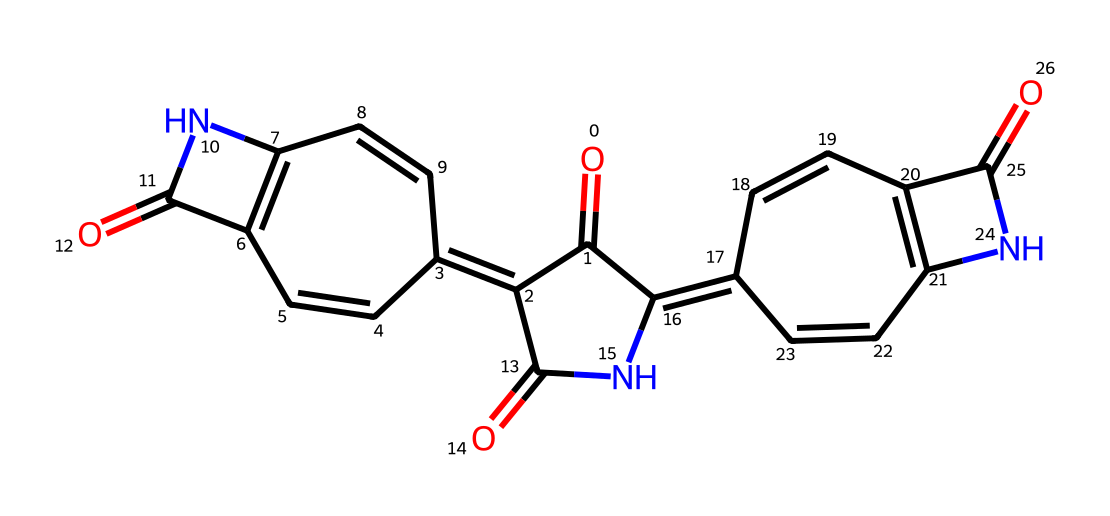What is the main functional group present in this chemical structure? The presence of carbonyl (C=O) groups, indicated by the double bonds to oxygen atoms, confirms that the main functional group is amide due to the nitrogen atoms adjacent to these carbonyls.
Answer: amide How many nitrogen atoms are in the chemical structure? By counting the nitrogen (N) symbols in the SMILES representation, there are two nitrogen atoms present in the structure.
Answer: two What type of hybridization do the carbon atoms in this ring structure primarily exhibit? The carbon atoms in this structure show sp2 hybridization due to the presence of double bonds and the planar nature required for the aromatic rings.
Answer: sp2 How many rings are present in the chemical structure of this dye? The chemical structure shows four fused aromatic rings, which can be identified by tracing the connections and overall shapes formed within the SMILES.
Answer: four What type of color does this chemical primarily produce when used as a dye? Indigo is known to produce a deep blue color when applied to fabrics, which is characteristic of its use in dyeing processes.
Answer: blue Does this chemical have herbicidal properties? This chemical is not known primarily for herbicidal properties but serves mainly as a dye; however, certain structural elements can suggest interactions with herbicide action.
Answer: no 